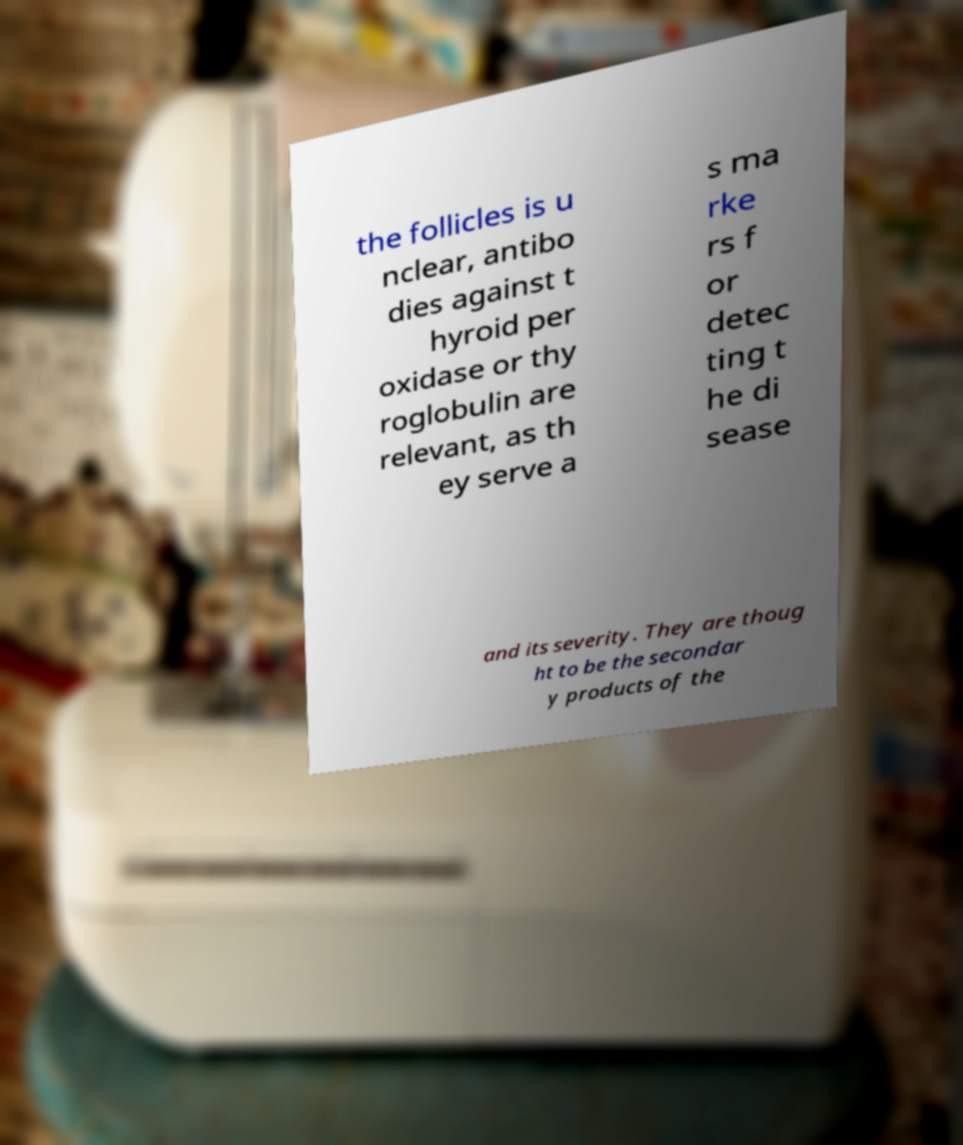Please identify and transcribe the text found in this image. the follicles is u nclear, antibo dies against t hyroid per oxidase or thy roglobulin are relevant, as th ey serve a s ma rke rs f or detec ting t he di sease and its severity. They are thoug ht to be the secondar y products of the 